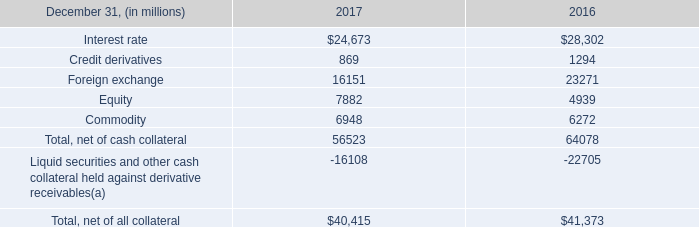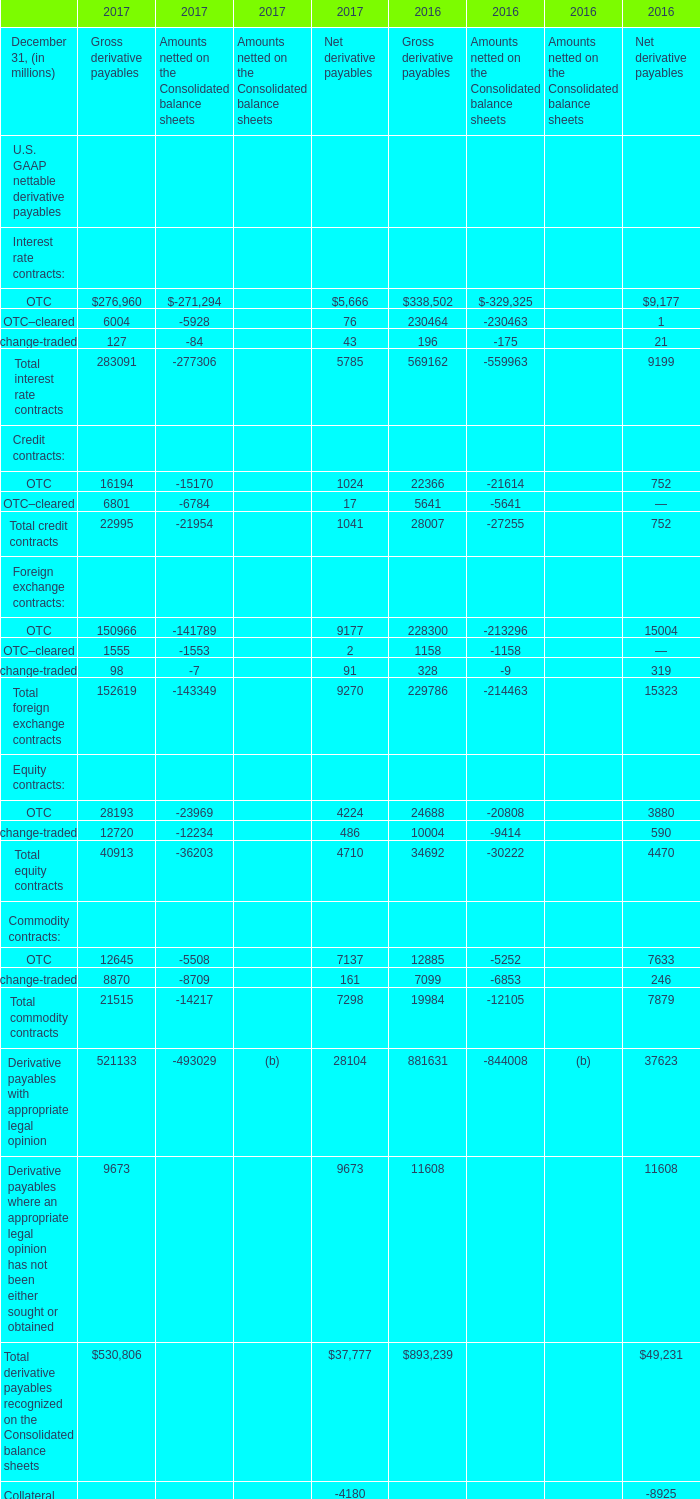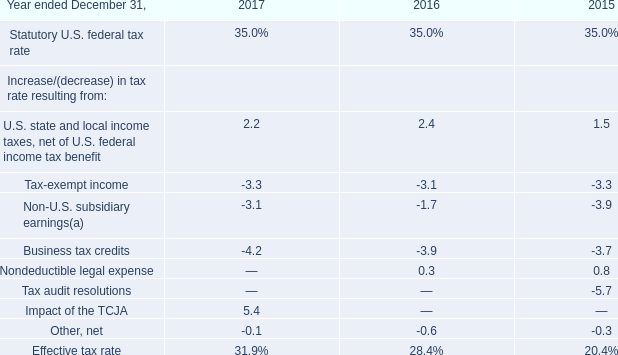Which year is the value of Gross derivative payables for Total equity contracts the most? 
Answer: 2017. 